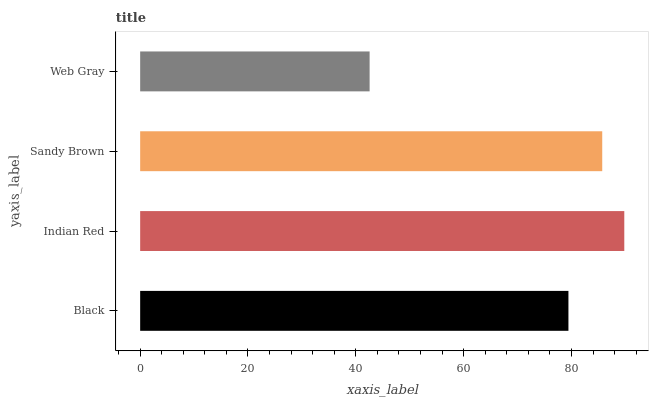Is Web Gray the minimum?
Answer yes or no. Yes. Is Indian Red the maximum?
Answer yes or no. Yes. Is Sandy Brown the minimum?
Answer yes or no. No. Is Sandy Brown the maximum?
Answer yes or no. No. Is Indian Red greater than Sandy Brown?
Answer yes or no. Yes. Is Sandy Brown less than Indian Red?
Answer yes or no. Yes. Is Sandy Brown greater than Indian Red?
Answer yes or no. No. Is Indian Red less than Sandy Brown?
Answer yes or no. No. Is Sandy Brown the high median?
Answer yes or no. Yes. Is Black the low median?
Answer yes or no. Yes. Is Web Gray the high median?
Answer yes or no. No. Is Sandy Brown the low median?
Answer yes or no. No. 